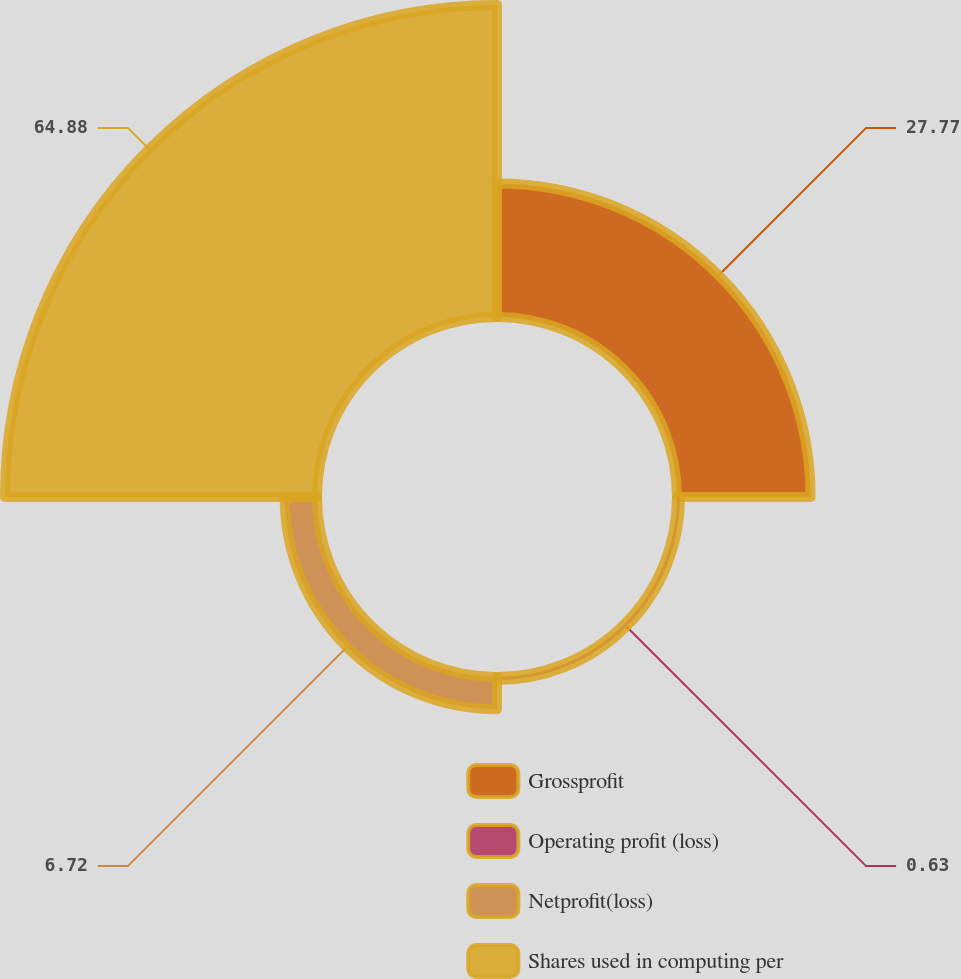Convert chart to OTSL. <chart><loc_0><loc_0><loc_500><loc_500><pie_chart><fcel>Grossprofit<fcel>Operating profit (loss)<fcel>Netprofit(loss)<fcel>Shares used in computing per<nl><fcel>27.77%<fcel>0.63%<fcel>6.72%<fcel>64.87%<nl></chart> 